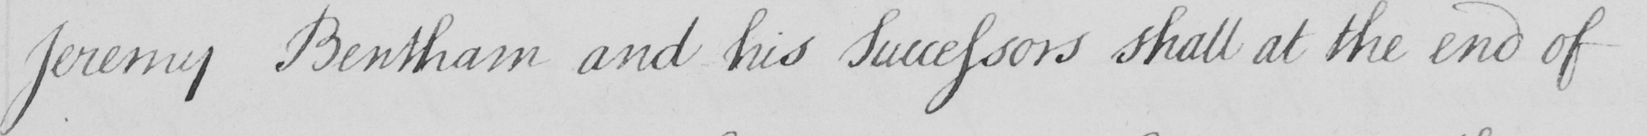What is written in this line of handwriting? Jeremy Bentham and his Successors shall at the end of 